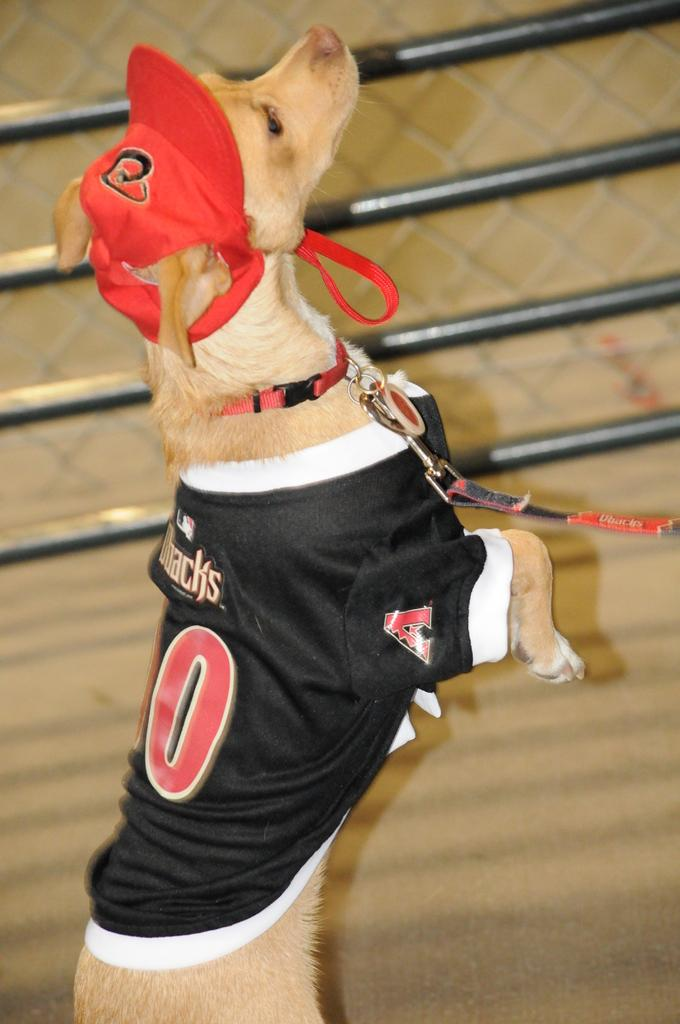<image>
Render a clear and concise summary of the photo. A dog with a red hat and a shirt on that says Poacks is standing on its back legs. 